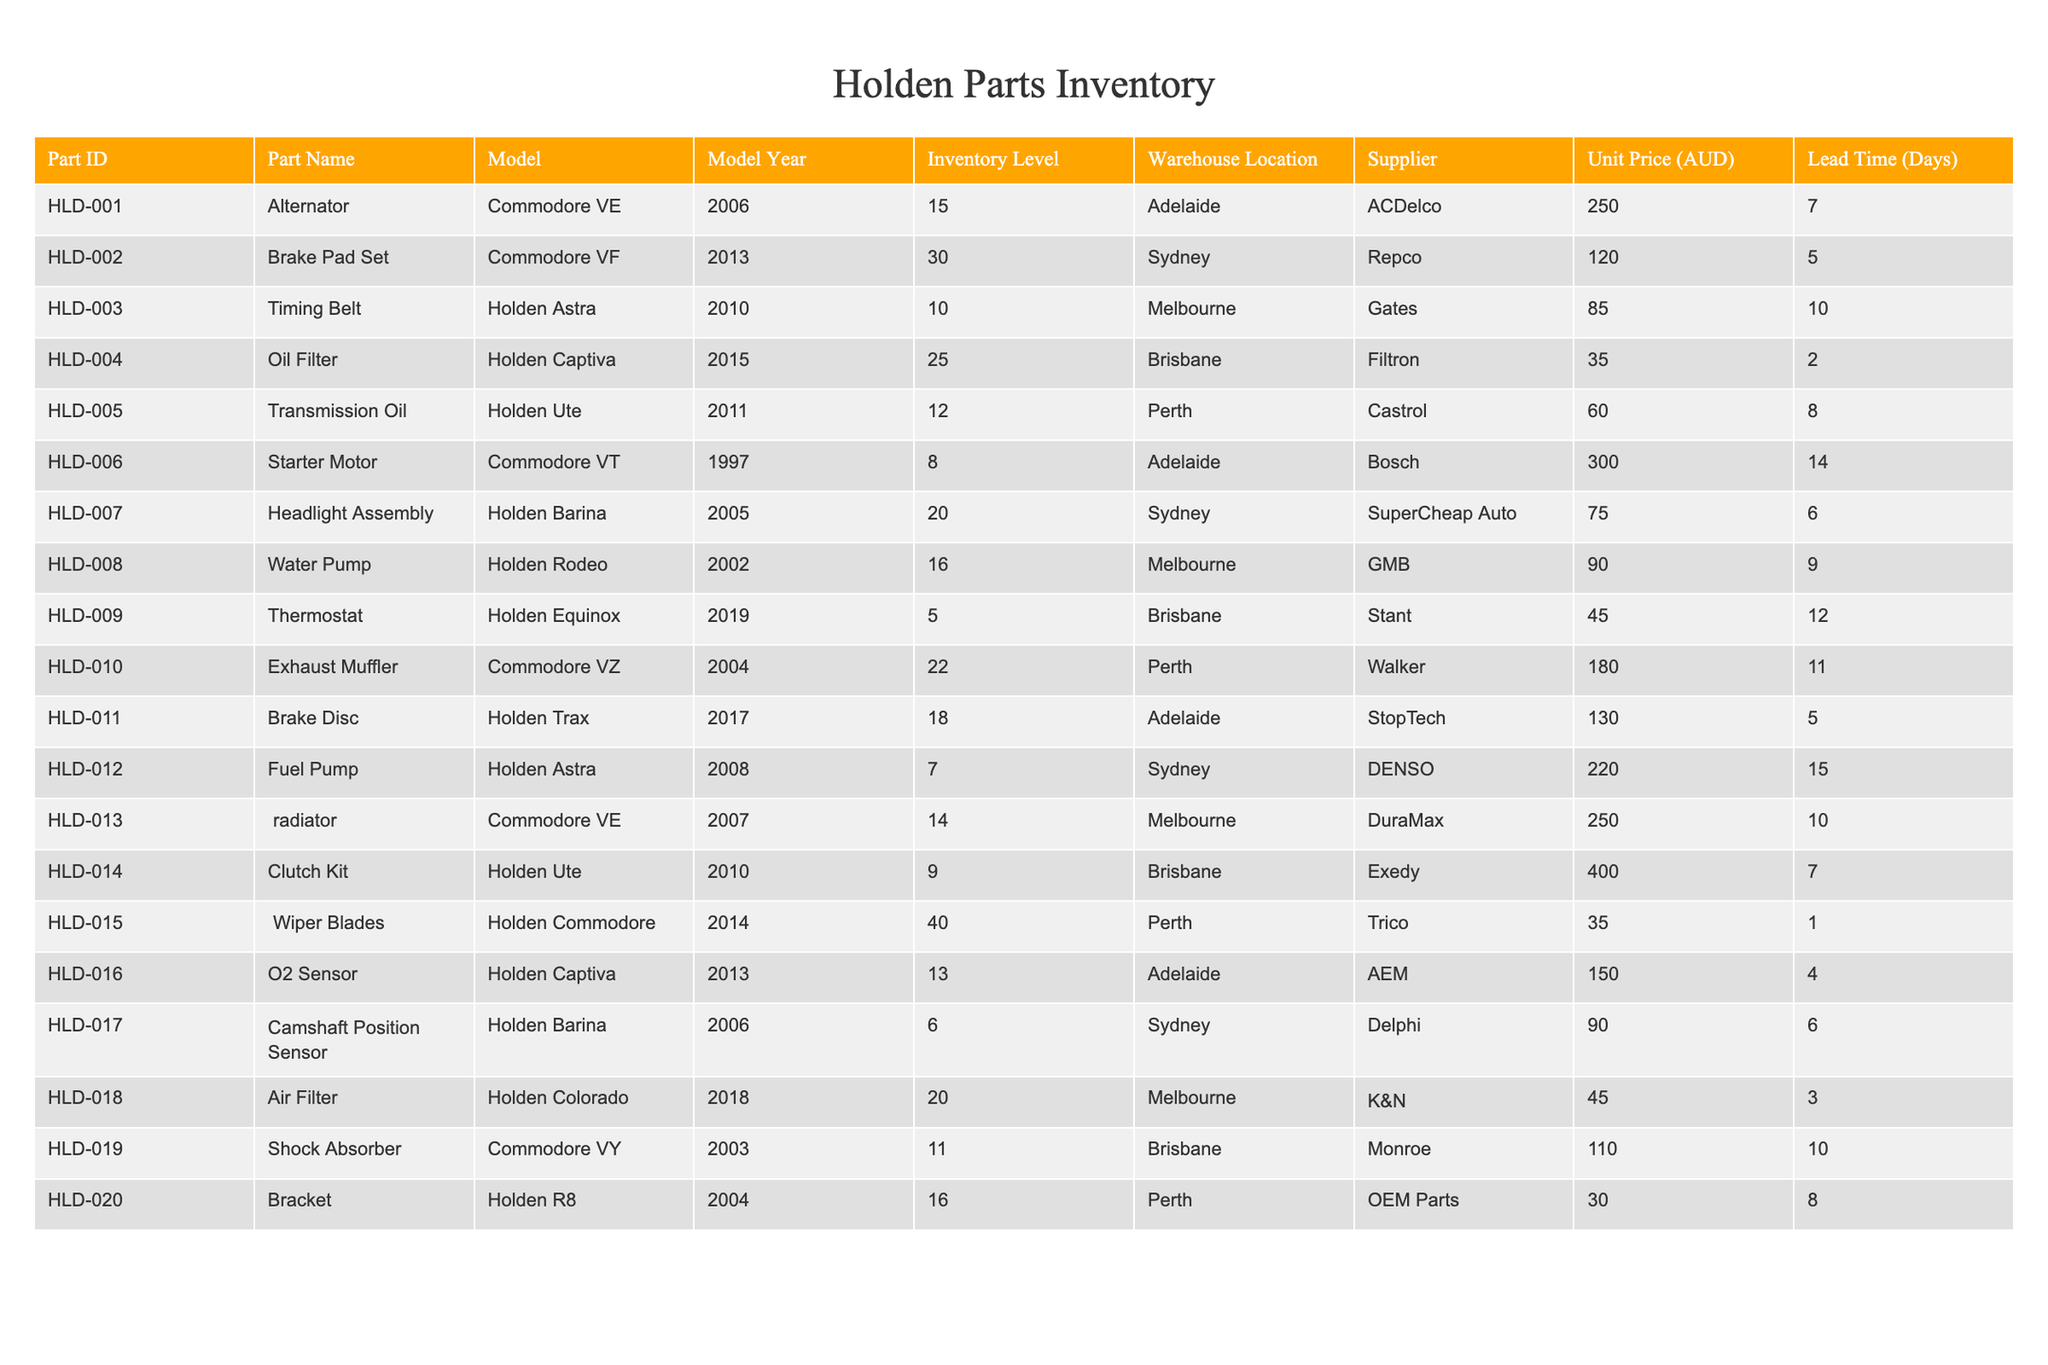What is the inventory level of the Brake Pad Set for the Commodore VF? The Brake Pad Set for the Commodore VF has an inventory level of 30 as indicated in the table.
Answer: 30 Which part has the highest unit price? By checking the 'Unit Price (AUD)' values in the table, the Clutch Kit for the Holden Ute has the highest price at 400 AUD.
Answer: 400 AUD How many parts have an inventory level below 10? Looking through the 'Inventory Level' column, the parts with levels below 10 are the Starter Motor (8), Fuel Pump (7), and Camshaft Position Sensor (6), which counts to 3 parts.
Answer: 3 What is the average lead time for parts in the table? To calculate, we add all the lead times: 7 + 5 + 10 + 2 + 8 + 14 + 6 + 9 + 12 + 11 + 5 + 15 + 10 + 7 + 1 + 4 + 6 + 3 + 10 + 8 =  159. Then we divide by 20 (number of parts), giving an average lead time of 159/20 = 7.95 days.
Answer: 7.95 days Is there any part with an inventory level of 0? Scanning the 'Inventory Level' column, none of the parts have a value of 0. Thus, the answer is no.
Answer: No Which model year has the most parts listed based on the given data? The model year 2014 has the most parts listed, specifically the Wiper Blades for the Holden Commodore with an inventory level of 40.
Answer: 2014 How many parts are from suppliers located in Sydney? From the table, there are 4 parts supplied by locations in Sydney: the Brake Pad Set, Fuel Pump, Headlight Assembly, and Camshaft Position Sensor.
Answer: 4 Which model requires a Thermostat and what is its inventory level? The Thermostat is required for the Holden Equinox, and its inventory level is 5 as shown in the table.
Answer: Holden Equinox, inventory level 5 What is the total inventory level for all Holden Ute parts? There are two parts related to the Holden Ute: Transmission Oil (12) and Clutch Kit (9), thus the total inventory level is 12 + 9 = 21.
Answer: 21 In which warehouse is the Oil Filter located? The Oil Filter is located in Brisbane, as per the 'Warehouse Location' column in the table.
Answer: Brisbane 